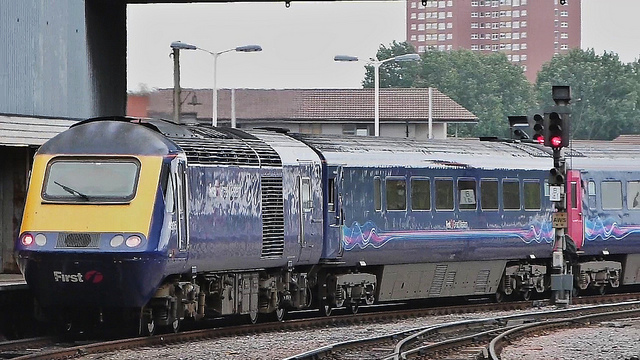Extract all visible text content from this image. First 